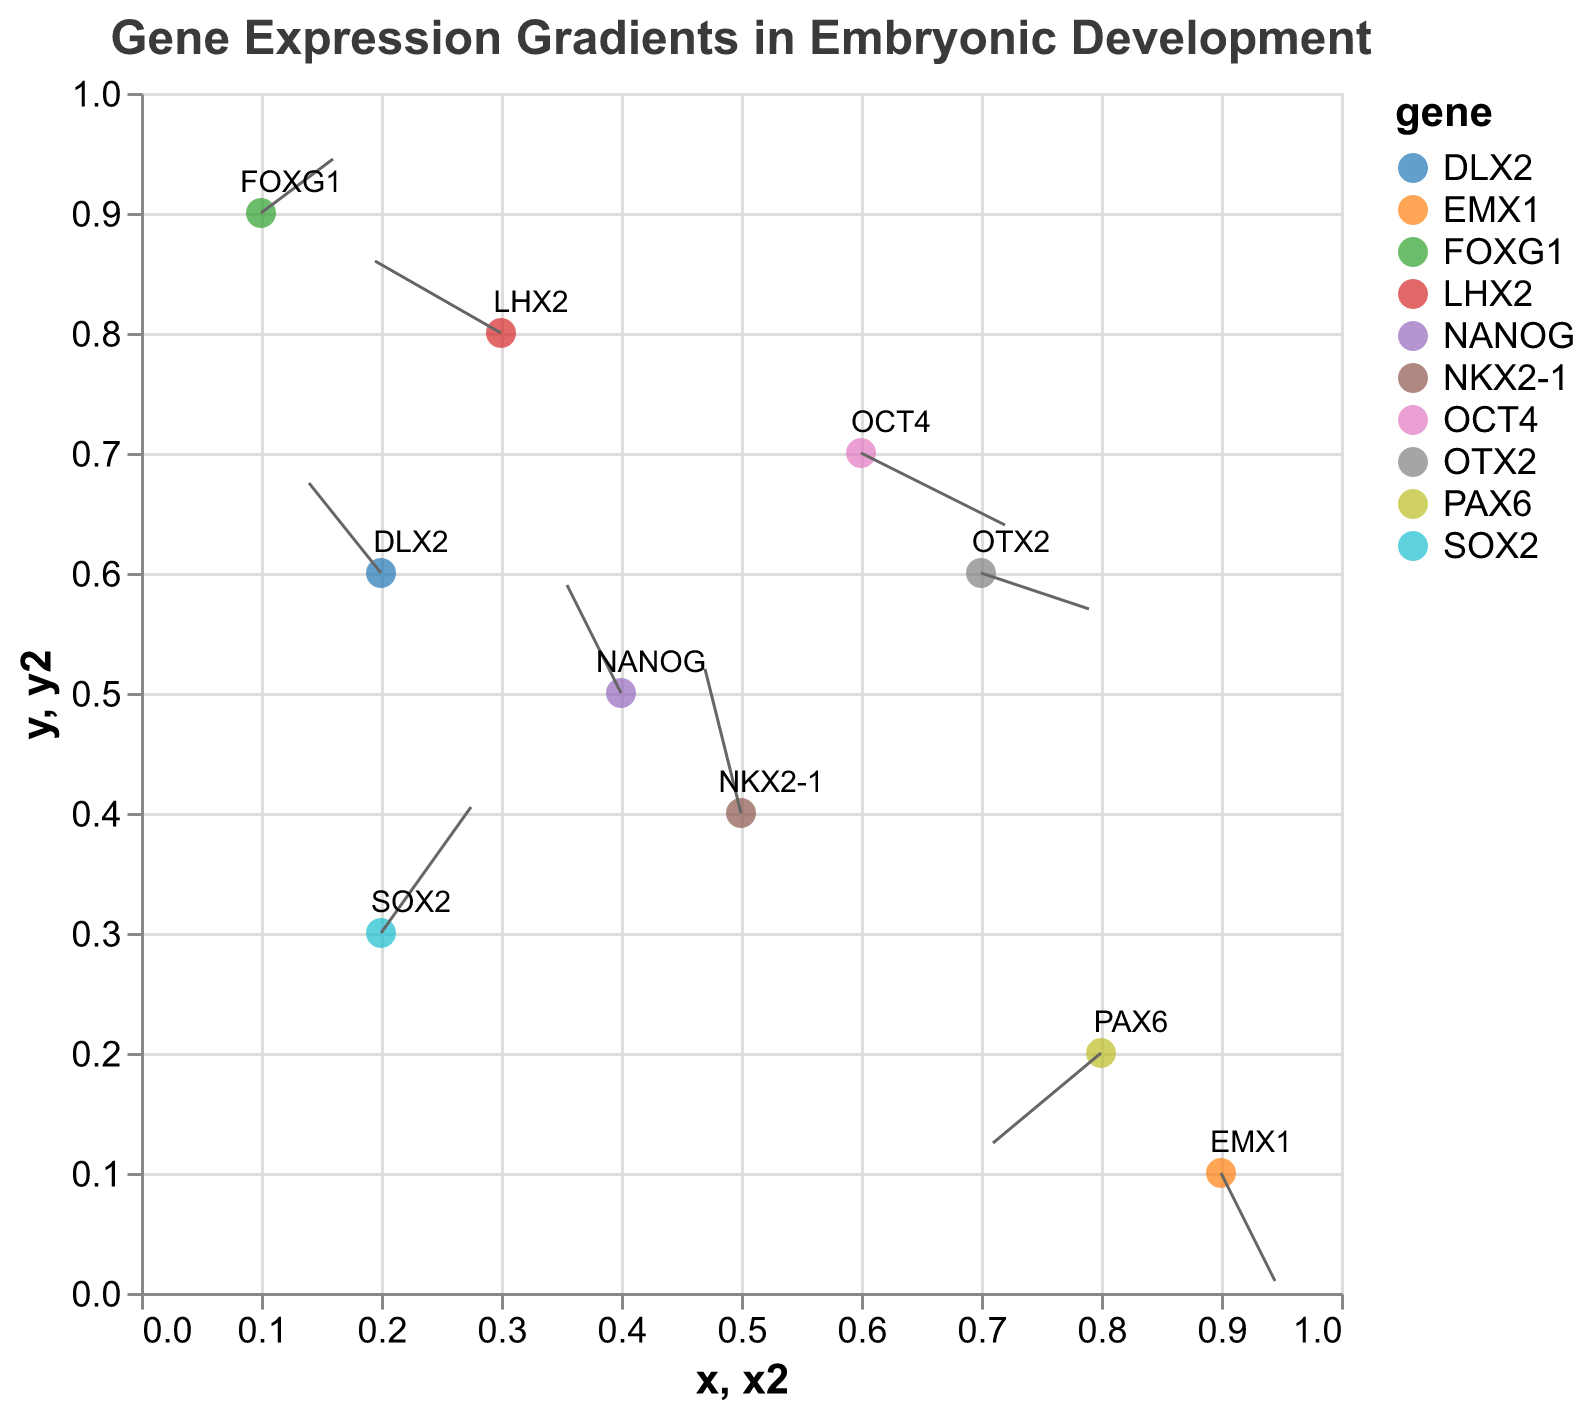What is the title of the plot? The plot's title is prominently displayed at the top of the figure. The text styling including font size, font type, and color enhance its visibility.
Answer: Gene Expression Gradients in Embryonic Development How many data points are represented in the plot? By counting the distinct points in the plot, each representing a gene with specific coordinates and directional vectors.
Answer: 10 Which gene's expression vector points to the lower-left direction? Review the vectors for those pointing towards the lower-left quadrant, specifically where both u (horizontal) and v (vertical) components are negative.
Answer: PAX6 Which gene shows the largest upward expression gradient? Compare the 'v' values across all genes, identifying the maximum positive value for interpretation of steepest upward gradient.
Answer: NKX2-1 What is the color of the data point representing the gene 'NANOG'? Identify the gene 'NANOG' and refer to the color legend to determine its corresponding color.
Answer: A specific nominal color from "category10", e.g., red (check the legend for exact color) What is the horizontal and vertical component of the gene 'OCT4'? Look at the data point labeled 'OCT4' and read its u (horizontal) and v (vertical) values from the tooltip or data labels.
Answer: Horizontal: 0.8, Vertical: -0.4 Which genes have expression vectors ending within the top half of the plot? Examine the endpoint 'y2' for each gene's vector and identify those where 'y2' > 0.5.
Answer: SOX2, NANOG, FOXG1, NKX2-1, DLX2 Which gene's expression gradient starts closest to the bottom-right corner? Review the coordinates (x, y) of each gene and identify the one nearest to (1, 0) based on visual estimate.
Answer: EMX1 